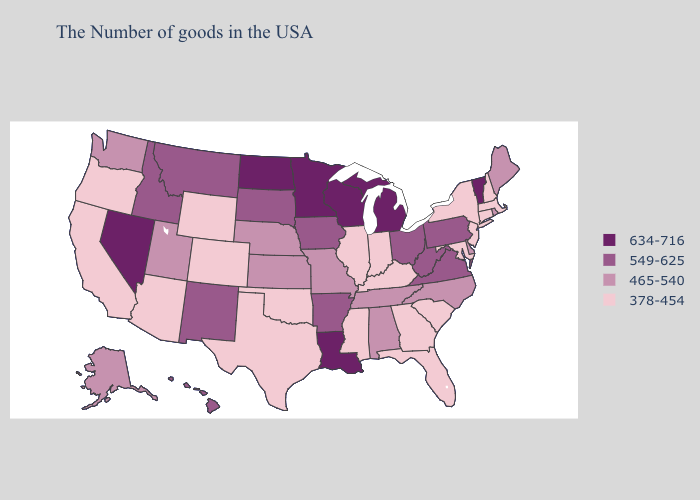Does Alaska have the lowest value in the USA?
Keep it brief. No. What is the value of Louisiana?
Short answer required. 634-716. What is the lowest value in states that border Montana?
Write a very short answer. 378-454. Does Vermont have the highest value in the Northeast?
Short answer required. Yes. What is the value of Washington?
Concise answer only. 465-540. Name the states that have a value in the range 634-716?
Quick response, please. Vermont, Michigan, Wisconsin, Louisiana, Minnesota, North Dakota, Nevada. Among the states that border Rhode Island , which have the highest value?
Keep it brief. Massachusetts, Connecticut. Does Kansas have a lower value than Idaho?
Concise answer only. Yes. What is the value of Georgia?
Keep it brief. 378-454. Does Massachusetts have the highest value in the Northeast?
Give a very brief answer. No. Name the states that have a value in the range 378-454?
Give a very brief answer. Massachusetts, New Hampshire, Connecticut, New York, New Jersey, Maryland, South Carolina, Florida, Georgia, Kentucky, Indiana, Illinois, Mississippi, Oklahoma, Texas, Wyoming, Colorado, Arizona, California, Oregon. What is the lowest value in states that border New Hampshire?
Concise answer only. 378-454. Does Connecticut have a lower value than Hawaii?
Be succinct. Yes. What is the value of Oklahoma?
Write a very short answer. 378-454. Is the legend a continuous bar?
Answer briefly. No. 